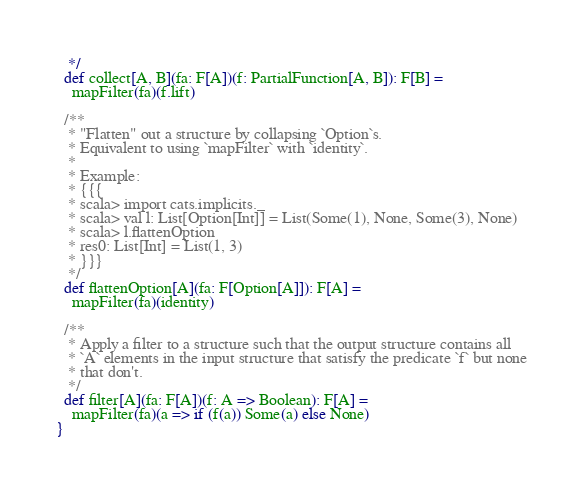Convert code to text. <code><loc_0><loc_0><loc_500><loc_500><_Scala_>   */
  def collect[A, B](fa: F[A])(f: PartialFunction[A, B]): F[B] =
    mapFilter(fa)(f.lift)

  /**
   * "Flatten" out a structure by collapsing `Option`s.
   * Equivalent to using `mapFilter` with `identity`.
   *
   * Example:
   * {{{
   * scala> import cats.implicits._
   * scala> val l: List[Option[Int]] = List(Some(1), None, Some(3), None)
   * scala> l.flattenOption
   * res0: List[Int] = List(1, 3)
   * }}}
   */
  def flattenOption[A](fa: F[Option[A]]): F[A] =
    mapFilter(fa)(identity)

  /**
   * Apply a filter to a structure such that the output structure contains all
   * `A` elements in the input structure that satisfy the predicate `f` but none
   * that don't.
   */
  def filter[A](fa: F[A])(f: A => Boolean): F[A] =
    mapFilter(fa)(a => if (f(a)) Some(a) else None)
}
</code> 